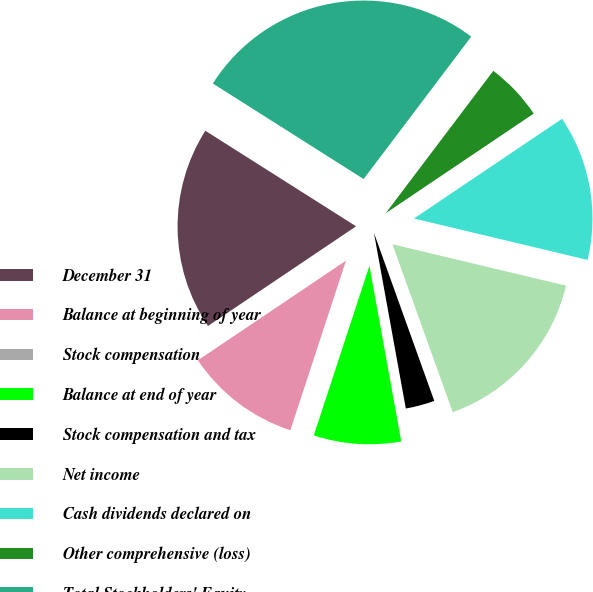Convert chart to OTSL. <chart><loc_0><loc_0><loc_500><loc_500><pie_chart><fcel>December 31<fcel>Balance at beginning of year<fcel>Stock compensation<fcel>Balance at end of year<fcel>Stock compensation and tax<fcel>Net income<fcel>Cash dividends declared on<fcel>Other comprehensive (loss)<fcel>Total Stockholders' Equity<nl><fcel>18.42%<fcel>10.53%<fcel>0.0%<fcel>7.9%<fcel>2.63%<fcel>15.79%<fcel>13.16%<fcel>5.27%<fcel>26.31%<nl></chart> 